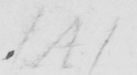Transcribe the text shown in this historical manuscript line. ( A ) 